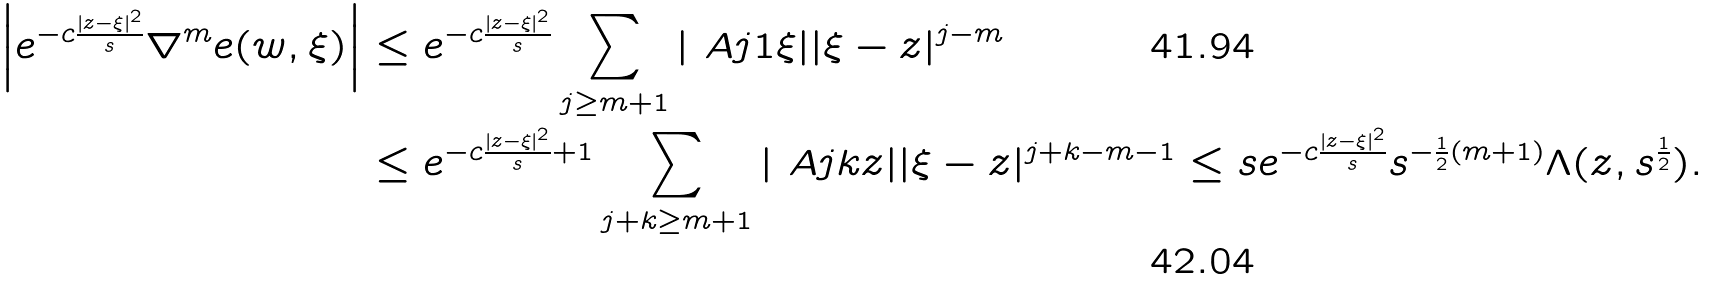Convert formula to latex. <formula><loc_0><loc_0><loc_500><loc_500>\left | e ^ { - c \frac { | z - \xi | ^ { 2 } } { s } } \nabla ^ { m } e ( w , \xi ) \right | & \leq e ^ { - c \frac { | z - \xi | ^ { 2 } } { s } } \sum _ { j \geq m + 1 } | \ A { j 1 } { \xi } | | \xi - z | ^ { j - m } \\ & \leq e ^ { - c \frac { | z - \xi | ^ { 2 } } { s } + 1 } \sum _ { j + k \geq m + 1 } | \ A { j k } { z } | | \xi - z | ^ { j + k - m - 1 } \leq s e ^ { - c \frac { | z - \xi | ^ { 2 } } { s } } s ^ { - \frac { 1 } { 2 } ( m + 1 ) } \Lambda ( z , s ^ { \frac { 1 } { 2 } } ) .</formula> 